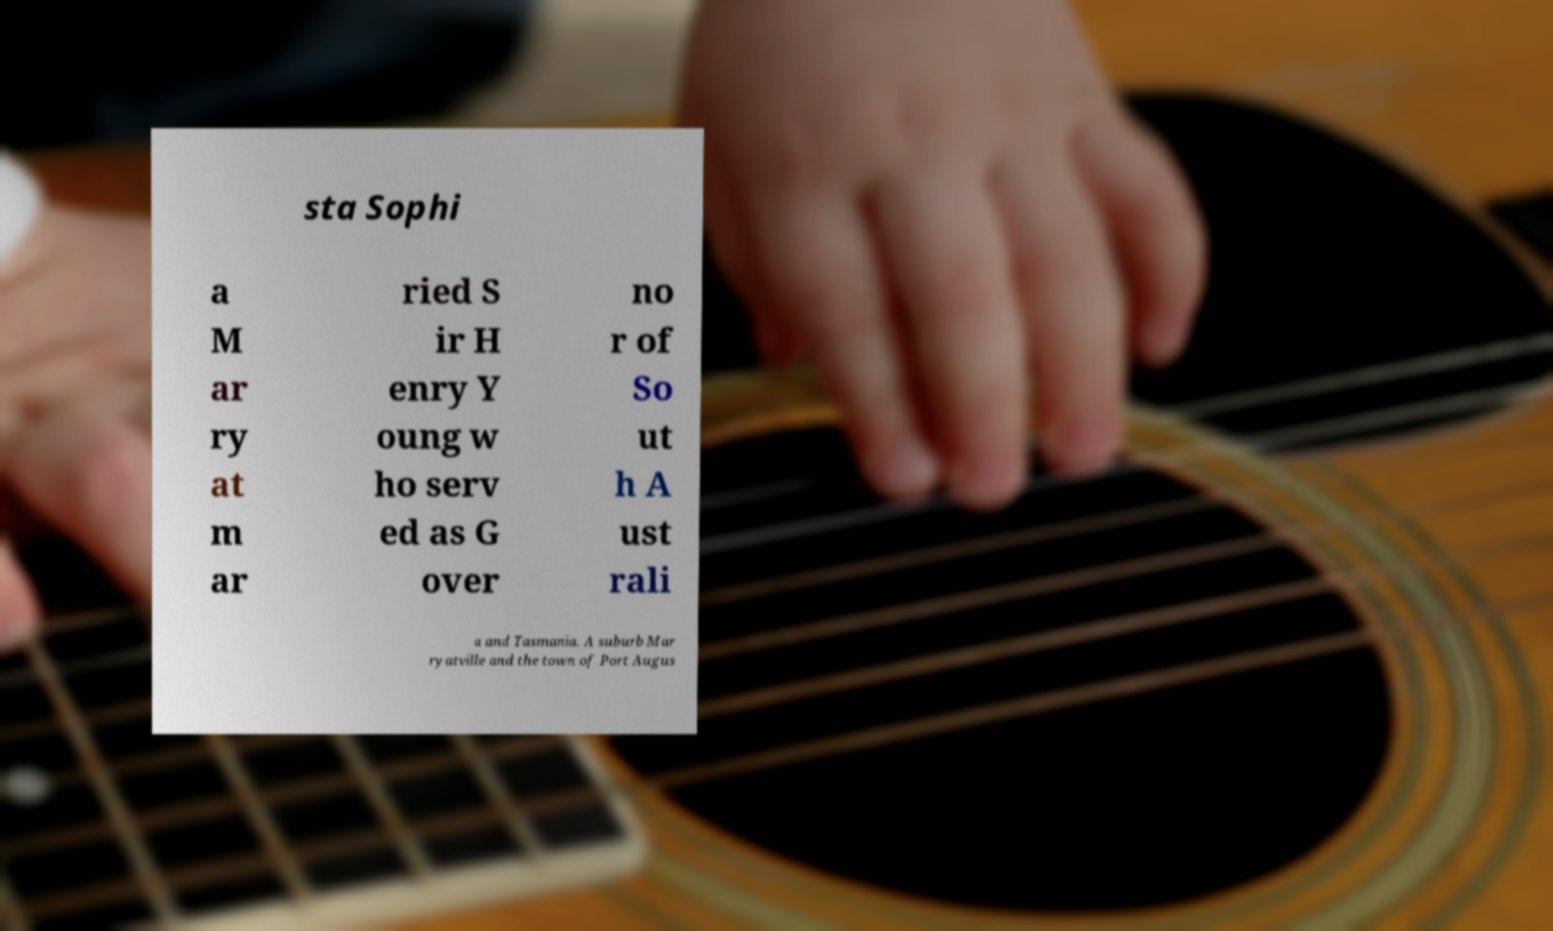Could you assist in decoding the text presented in this image and type it out clearly? sta Sophi a M ar ry at m ar ried S ir H enry Y oung w ho serv ed as G over no r of So ut h A ust rali a and Tasmania. A suburb Mar ryatville and the town of Port Augus 